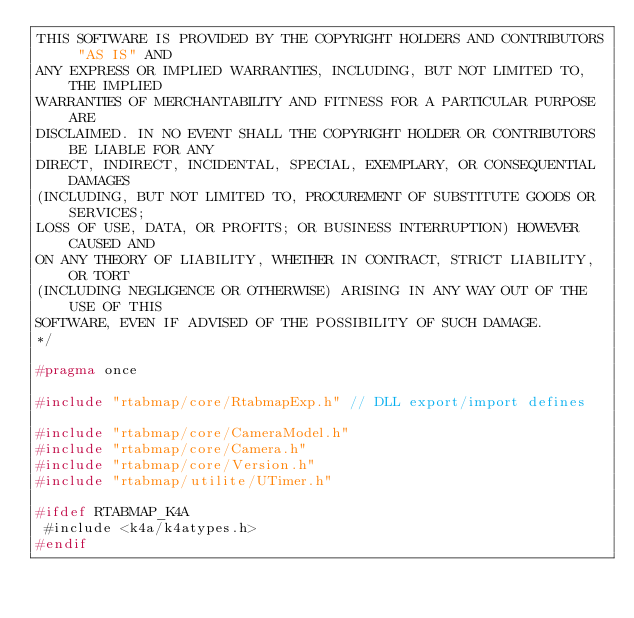<code> <loc_0><loc_0><loc_500><loc_500><_C_>THIS SOFTWARE IS PROVIDED BY THE COPYRIGHT HOLDERS AND CONTRIBUTORS "AS IS" AND
ANY EXPRESS OR IMPLIED WARRANTIES, INCLUDING, BUT NOT LIMITED TO, THE IMPLIED
WARRANTIES OF MERCHANTABILITY AND FITNESS FOR A PARTICULAR PURPOSE ARE
DISCLAIMED. IN NO EVENT SHALL THE COPYRIGHT HOLDER OR CONTRIBUTORS BE LIABLE FOR ANY
DIRECT, INDIRECT, INCIDENTAL, SPECIAL, EXEMPLARY, OR CONSEQUENTIAL DAMAGES
(INCLUDING, BUT NOT LIMITED TO, PROCUREMENT OF SUBSTITUTE GOODS OR SERVICES;
LOSS OF USE, DATA, OR PROFITS; OR BUSINESS INTERRUPTION) HOWEVER CAUSED AND
ON ANY THEORY OF LIABILITY, WHETHER IN CONTRACT, STRICT LIABILITY, OR TORT
(INCLUDING NEGLIGENCE OR OTHERWISE) ARISING IN ANY WAY OUT OF THE USE OF THIS
SOFTWARE, EVEN IF ADVISED OF THE POSSIBILITY OF SUCH DAMAGE.
*/

#pragma once

#include "rtabmap/core/RtabmapExp.h" // DLL export/import defines

#include "rtabmap/core/CameraModel.h"
#include "rtabmap/core/Camera.h"
#include "rtabmap/core/Version.h"
#include "rtabmap/utilite/UTimer.h"

#ifdef RTABMAP_K4A
 #include <k4a/k4atypes.h>
#endif
</code> 